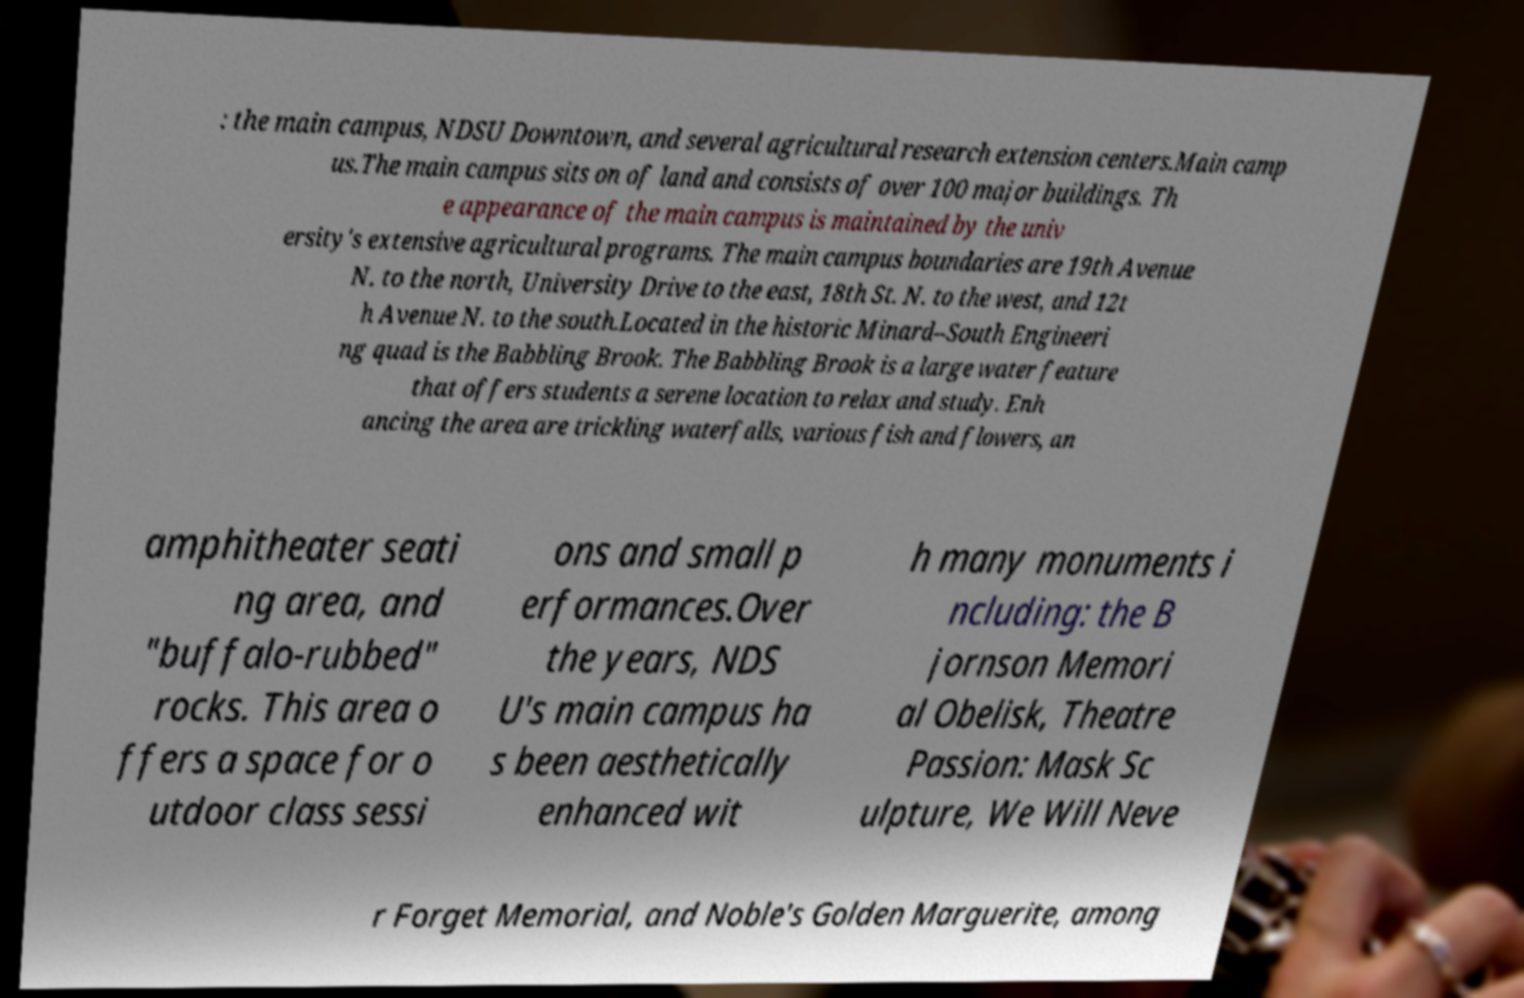Please identify and transcribe the text found in this image. : the main campus, NDSU Downtown, and several agricultural research extension centers.Main camp us.The main campus sits on of land and consists of over 100 major buildings. Th e appearance of the main campus is maintained by the univ ersity's extensive agricultural programs. The main campus boundaries are 19th Avenue N. to the north, University Drive to the east, 18th St. N. to the west, and 12t h Avenue N. to the south.Located in the historic Minard–South Engineeri ng quad is the Babbling Brook. The Babbling Brook is a large water feature that offers students a serene location to relax and study. Enh ancing the area are trickling waterfalls, various fish and flowers, an amphitheater seati ng area, and "buffalo-rubbed" rocks. This area o ffers a space for o utdoor class sessi ons and small p erformances.Over the years, NDS U's main campus ha s been aesthetically enhanced wit h many monuments i ncluding: the B jornson Memori al Obelisk, Theatre Passion: Mask Sc ulpture, We Will Neve r Forget Memorial, and Noble's Golden Marguerite, among 